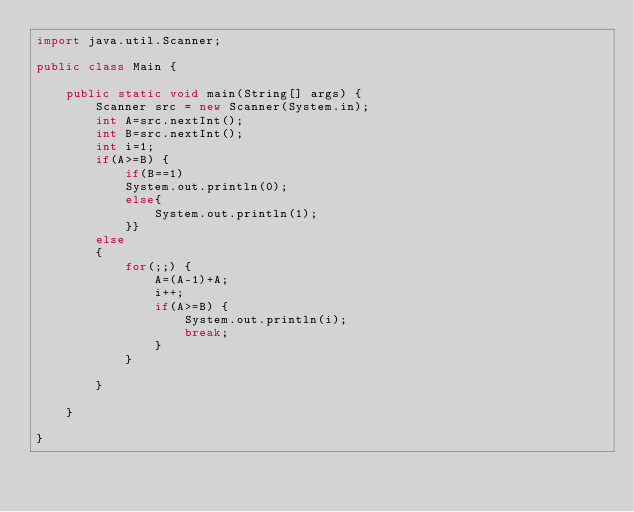<code> <loc_0><loc_0><loc_500><loc_500><_Java_>import java.util.Scanner;

public class Main {

	public static void main(String[] args) {
		Scanner src = new Scanner(System.in);
		int A=src.nextInt();
		int B=src.nextInt();
		int i=1;
		if(A>=B) {
			if(B==1)
			System.out.println(0);
			else{
				System.out.println(1);
			}}
		else
		{
			for(;;) {
				A=(A-1)+A;
				i++;
				if(A>=B) {
					System.out.println(i);
					break;
				}
			}
			
		}

	}

}
</code> 